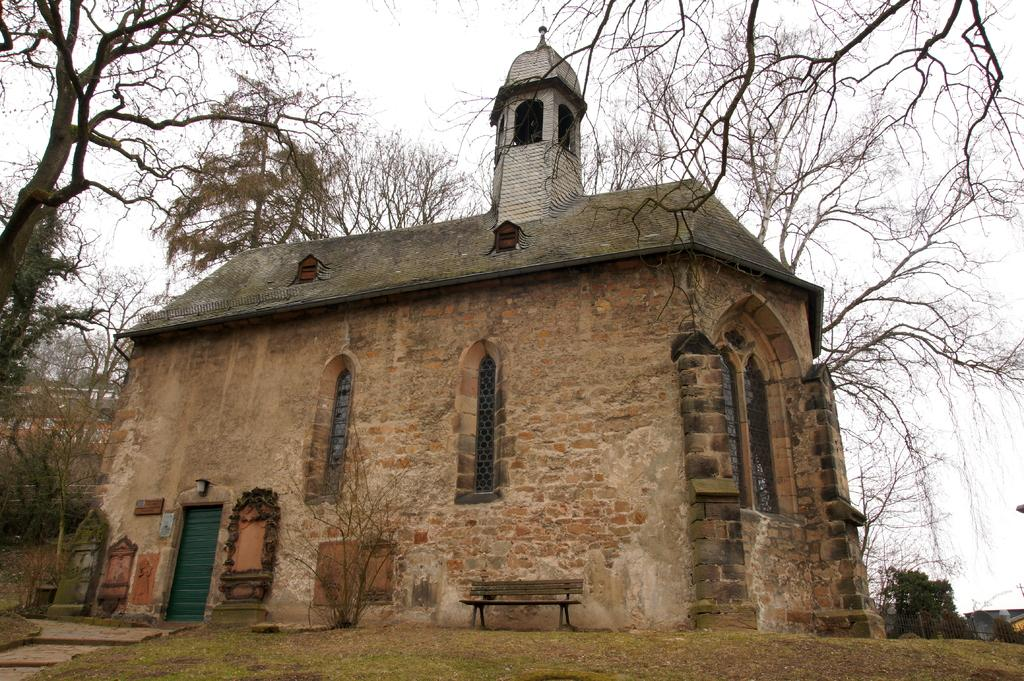What type of building is in the image? There is a Chapel in the image. What color is the door of the Chapel? The Chapel has a green door. What is located next to the Chapel? There is a bench next to the Chapel. What is placed next to the bench? There is a plant next to the bench. What type of ground surface is visible in the image? There is grass in the image. What can be seen in the background of the image? There are trees in the background of the image. What part of the natural environment is visible in the image? The sky is visible in the image. How many chairs are placed around the unit in the image? There is no unit or chairs present in the image; it features a Chapel with a green door, a bench, a plant, grass, trees, and the sky. 